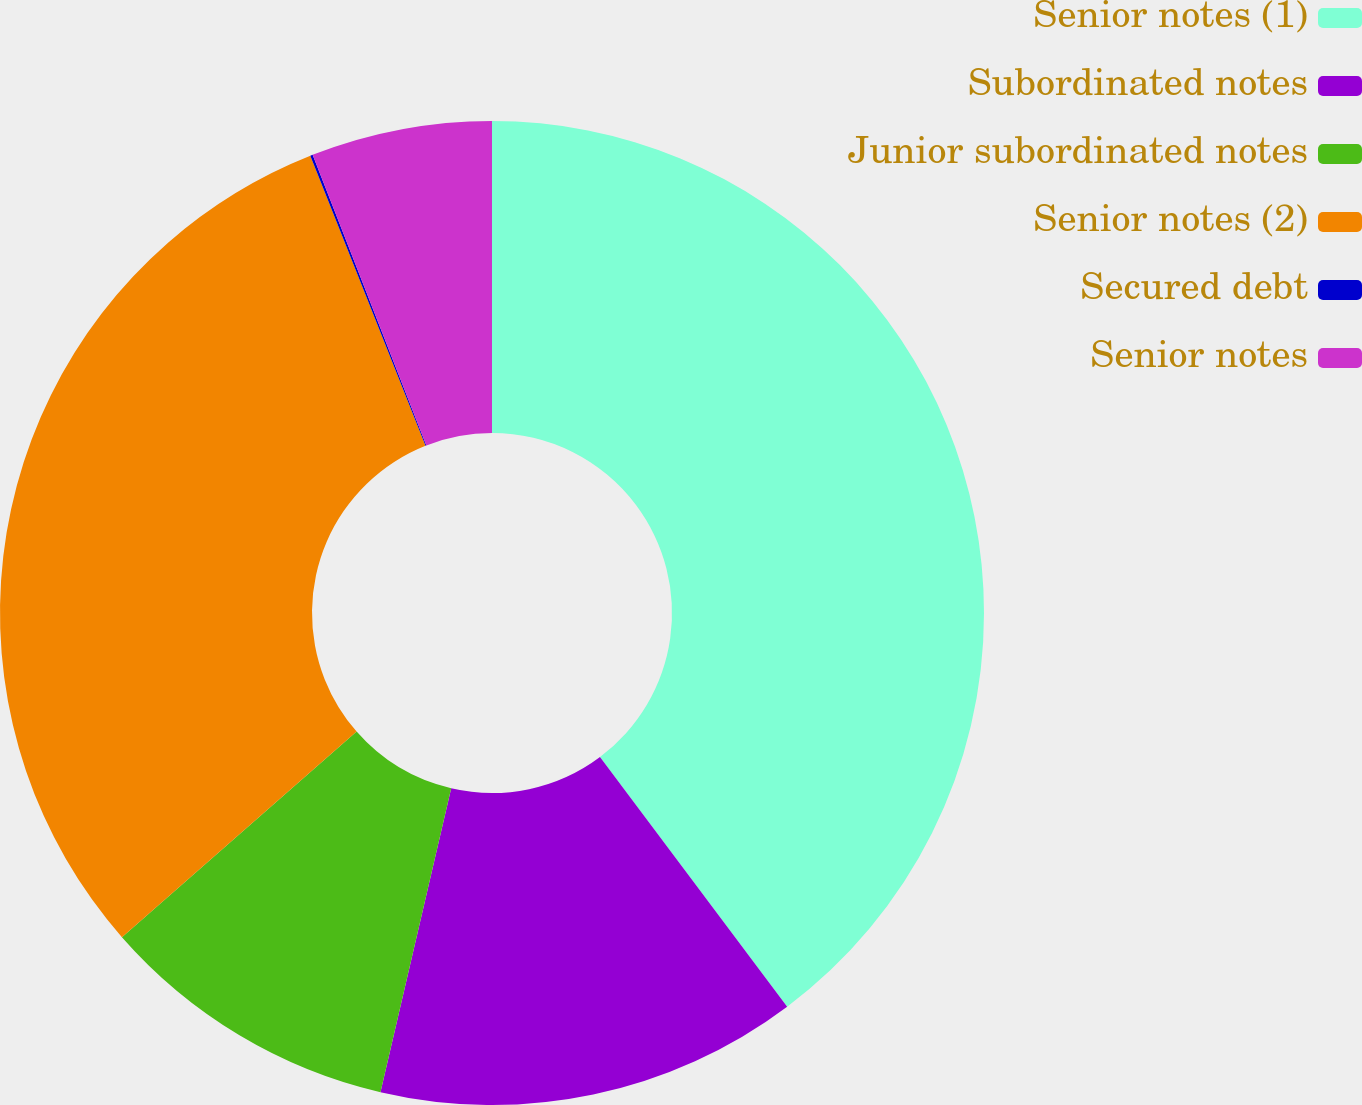Convert chart to OTSL. <chart><loc_0><loc_0><loc_500><loc_500><pie_chart><fcel>Senior notes (1)<fcel>Subordinated notes<fcel>Junior subordinated notes<fcel>Senior notes (2)<fcel>Secured debt<fcel>Senior notes<nl><fcel>39.76%<fcel>13.88%<fcel>9.91%<fcel>30.43%<fcel>0.08%<fcel>5.94%<nl></chart> 